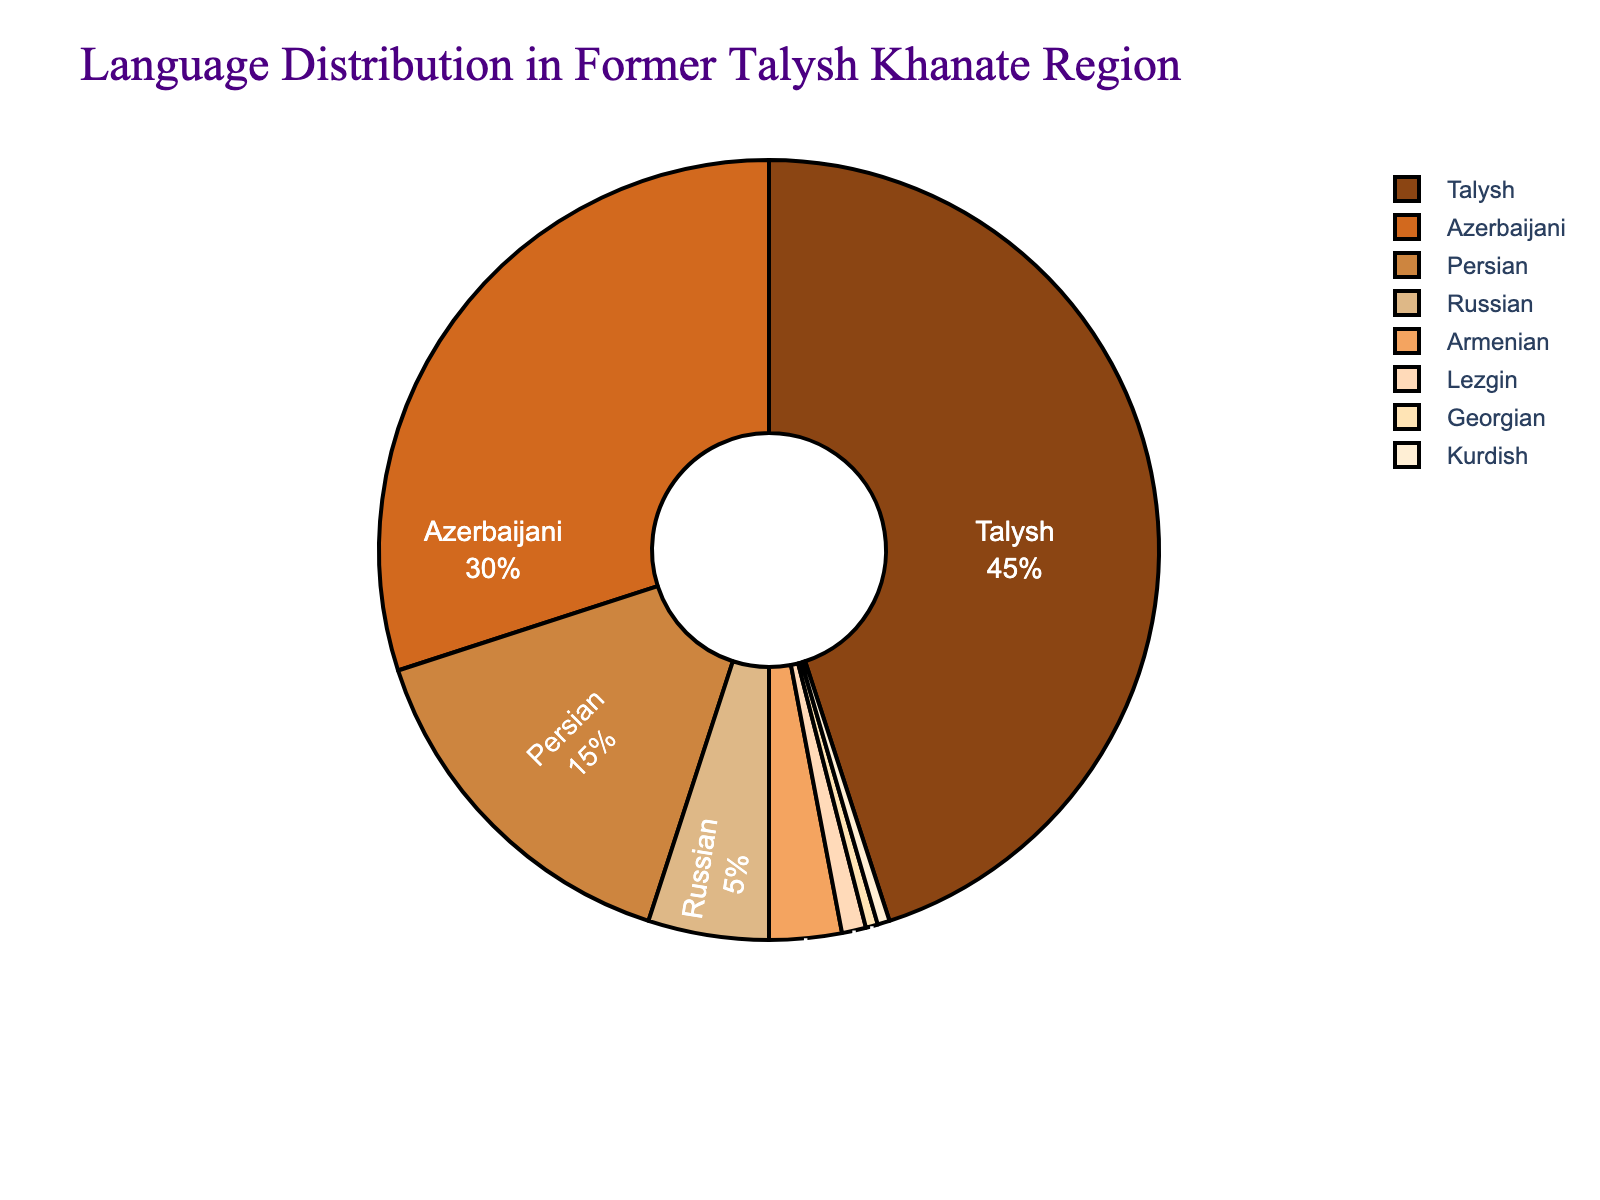What percentage of languages other than Talysh are spoken in the former Talysh Khanate region? To find the percentage of languages other than Talysh, subtract the percentage of Talysh speakers from 100%: 100% - 45% = 55%
Answer: 55% What is the combined percentage of Azerbaijani and Persian speakers in the region? Add the percentages of Azerbaijani and Persian speakers: 30% + 15% = 45%
Answer: 45% Which language has the smallest representation in the region? From the data, the languages with the smallest representation are Georgian and Kurdish, both at 0.5%.
Answer: Georgian and Kurdish By how many percentage points does the Talysh language lead Azerbaijani in terms of speakers? Subtract the percentage of Azerbaijani speakers from the Talysh speakers: 45% - 30% = 15%
Answer: 15% What’s the difference in percentage between the combined share of Russian and Armenian speakers versus only Persian speakers? First, find the combined percentage for Russian and Armenian: 5% + 3% = 8%. Then, subtract the percentage of Persian speakers from this combined value: 8% - 15% = -7%
Answer: -7% Which two languages combined make up the same percentage as Talysh speakers? The combined percentages of Azerbaijani and Persian: 30% + 15% = 45% is equal to the percentage of Talysh speakers.
Answer: Azerbaijani and Persian What is the total percentage of speakers for the least represented languages (under 5%)? Add percentages for Russian, Armenian, Lezgin, Georgian, and Kurdish (5% + 3% + 1% + 0.5% + 0.5%): 10%
Answer: 10% Which language is represented by the darkest color in the chart and why? The darkest color in the pie chart is likely due to the ordering of the custom color palette. Since the first color listed is assigned to Talysh and it's the first and largest segment, it’s the likely answer.
Answer: Talysh Is the percentage of Russian speakers greater than the combined percentage of Lezgin, Georgian, and Kurdish speakers? First, sum the percentages of Lezgin, Georgian, and Kurdish: 1% + 0.5% + 0.5% = 2%. Since 5% (Russian) > 2%, yes, it is greater.
Answer: Yes How does the percentage of Armenian speakers compare to the percentage of Lezgin speakers? The Armenian percentage is 3%, and the Lezgin percentage is 1%; thus, Armenian speakers are represented three times as much as Lezgin speakers.
Answer: Three times more 